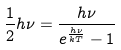<formula> <loc_0><loc_0><loc_500><loc_500>\frac { 1 } { 2 } h \nu = \frac { h \nu } { e ^ { \frac { h \nu } { k T } } - 1 }</formula> 